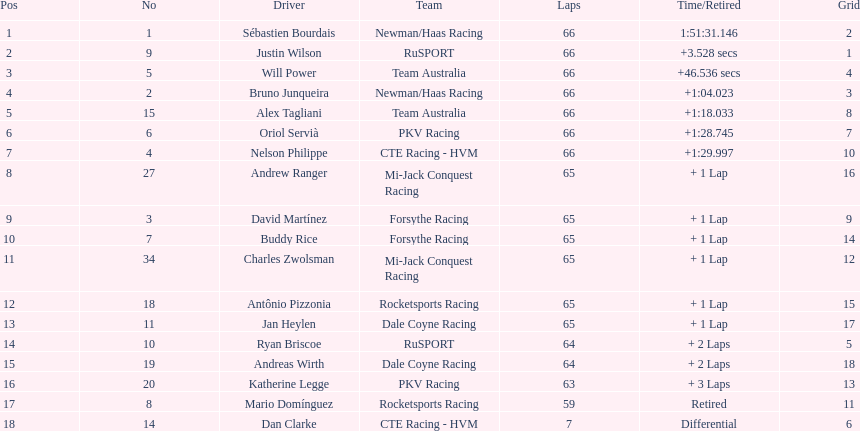At the 2006 gran premio telmex, how many drivers completed less than 60 laps? 2. 